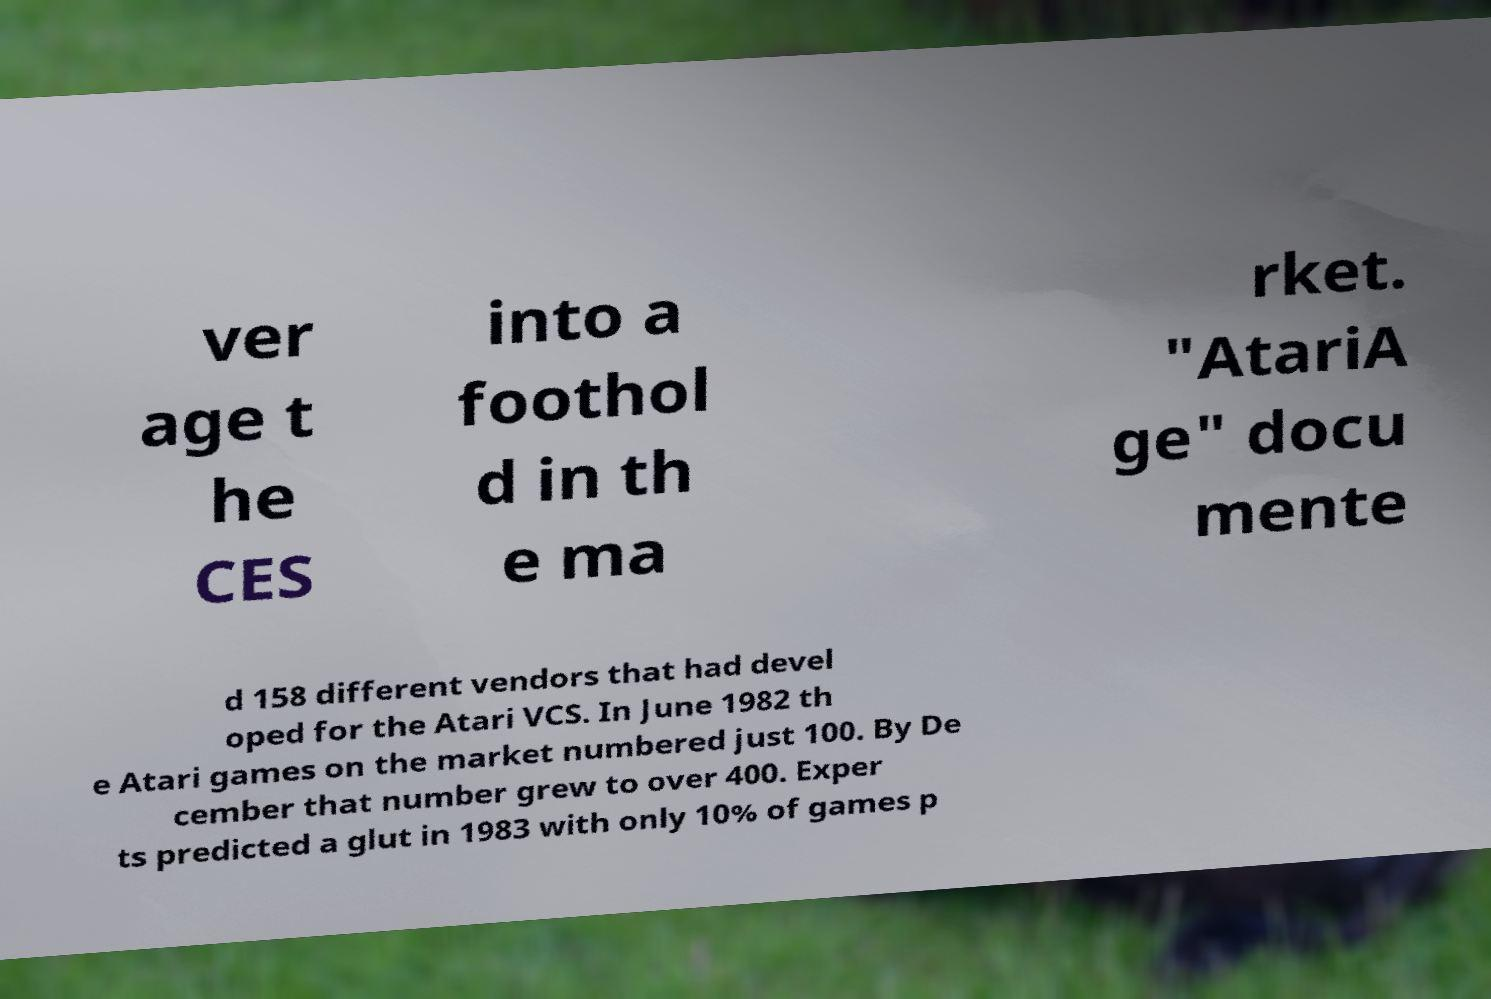For documentation purposes, I need the text within this image transcribed. Could you provide that? ver age t he CES into a foothol d in th e ma rket. "AtariA ge" docu mente d 158 different vendors that had devel oped for the Atari VCS. In June 1982 th e Atari games on the market numbered just 100. By De cember that number grew to over 400. Exper ts predicted a glut in 1983 with only 10% of games p 